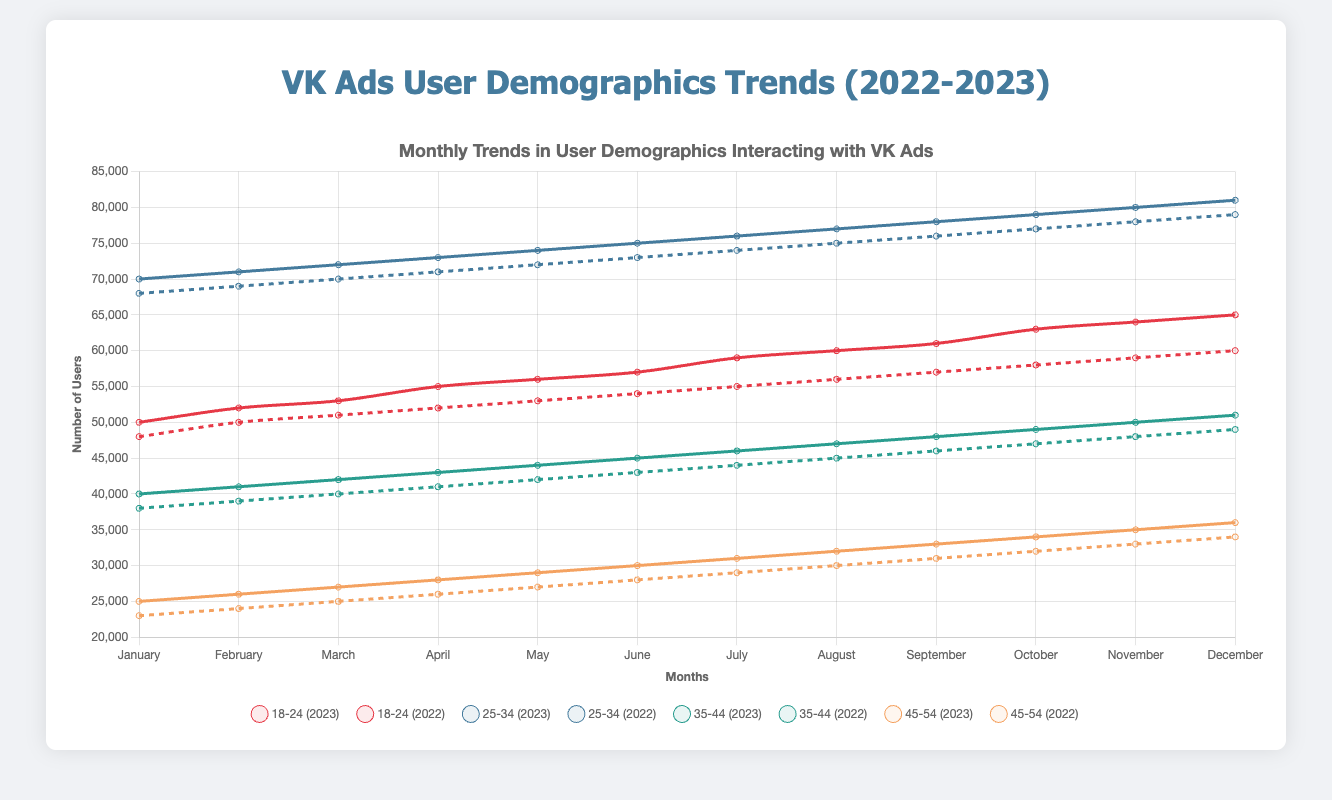What was the total number of users in the 18-24 and 25-34 age groups interacting with VK ads in December 2023? To find the total number of users in the 18-24 and 25-34 age groups, we add the values for December 2023 from both age groups. For 18-24, it's 65,000 and for 25-34, it's 81,000. Summing these values gives us 65,000 + 81,000 = 146,000.
Answer: 146,000 Which gender had more users interacting with VK ads in March 2023? By comparing the values for March 2023, we see that the number of male users was 84,000 and the number of female users was 104,000. Since 104,000 is greater than 84,000, females had more users.
Answer: Female Did the 35-44 age group show a higher increase in users from January to December 2023 compared to the 45-54 age group? To find the increase for each age group, we subtract January values from December values. For 35-44: 51,000 - 40,000 = 11,000. For 45-54: 36,000 - 25,000 = 11,000. Both age groups had the same increase of 11,000 users.
Answer: No Which city showed the most significant increase in the number of users interacting with VK ads from January 2022 to January 2023? Comparing January 2022 and January 2023 for each city, we calculate: 
Moscow: 50,000 - 48,000 = 2,000;
Saint Petersburg: 40,000 - 38,000 = 2,000;
Novosibirsk: 20,000 - 18,000 = 2,000;
Yekaterinburg: 15,000 - 13,000 = 2,000.
All cities showed equal increases of 2,000 users.
Answer: None (all equal) What month in 2023 saw the highest number of users in the 25-34 age group? By inspecting the 2023 data for the 25-34 age group, the highest number is in December, with 81,000 users.
Answer: December Which age group had a larger user base in December 2023: the 18-24s or the 35-44s? By comparing the values for December 2023 for both groups: 18-24 had 65,000 users, and 35-44 had 51,000 users. Since 65,000 is greater than 51,000, the 18-24 age group had a larger user base.
Answer: 18-24 By how much did the number of female users interacting with VK ads grow from January to December 2023? To determine the growth, we subtract the January value from the December value for females: 122,000 - 100,000 = 22,000.
Answer: 22,000 What is the divergence in user growth between the 35-44 and 45-54 age groups from January to December 2023? First, find the increase for each group from January to December 2023: 
35-44: 51,000 - 40,000 = 11,000; 
45-54: 36,000 - 25,000 = 11,000. 
Since both age groups have the same growth, the divergence is 0.
Answer: 0 Which month in 2023 had the lowest number of users among all age groups? By inspecting the data for 2023 across all age groups, July shows the lowest numbers:
18-24: 59,000; 25-34: 76,000; 35-44: 46,000; 45-54: 31,000. 
July has the overall lowest counts.
Answer: July Comparing the monthly trend between January and December 2023 for Moscow and Saint Petersburg, which city had a higher percent increase in users? Calculate the percent increase for both cities:
Moscow: ((61,000 - 50,000) / 50,000) * 100 = 22%;
Saint Petersburg: ((51,000 - 40,000) / 40,000) * 100 = 27.5%. 
Saint Petersburg had a higher percent increase.
Answer: Saint Petersburg 